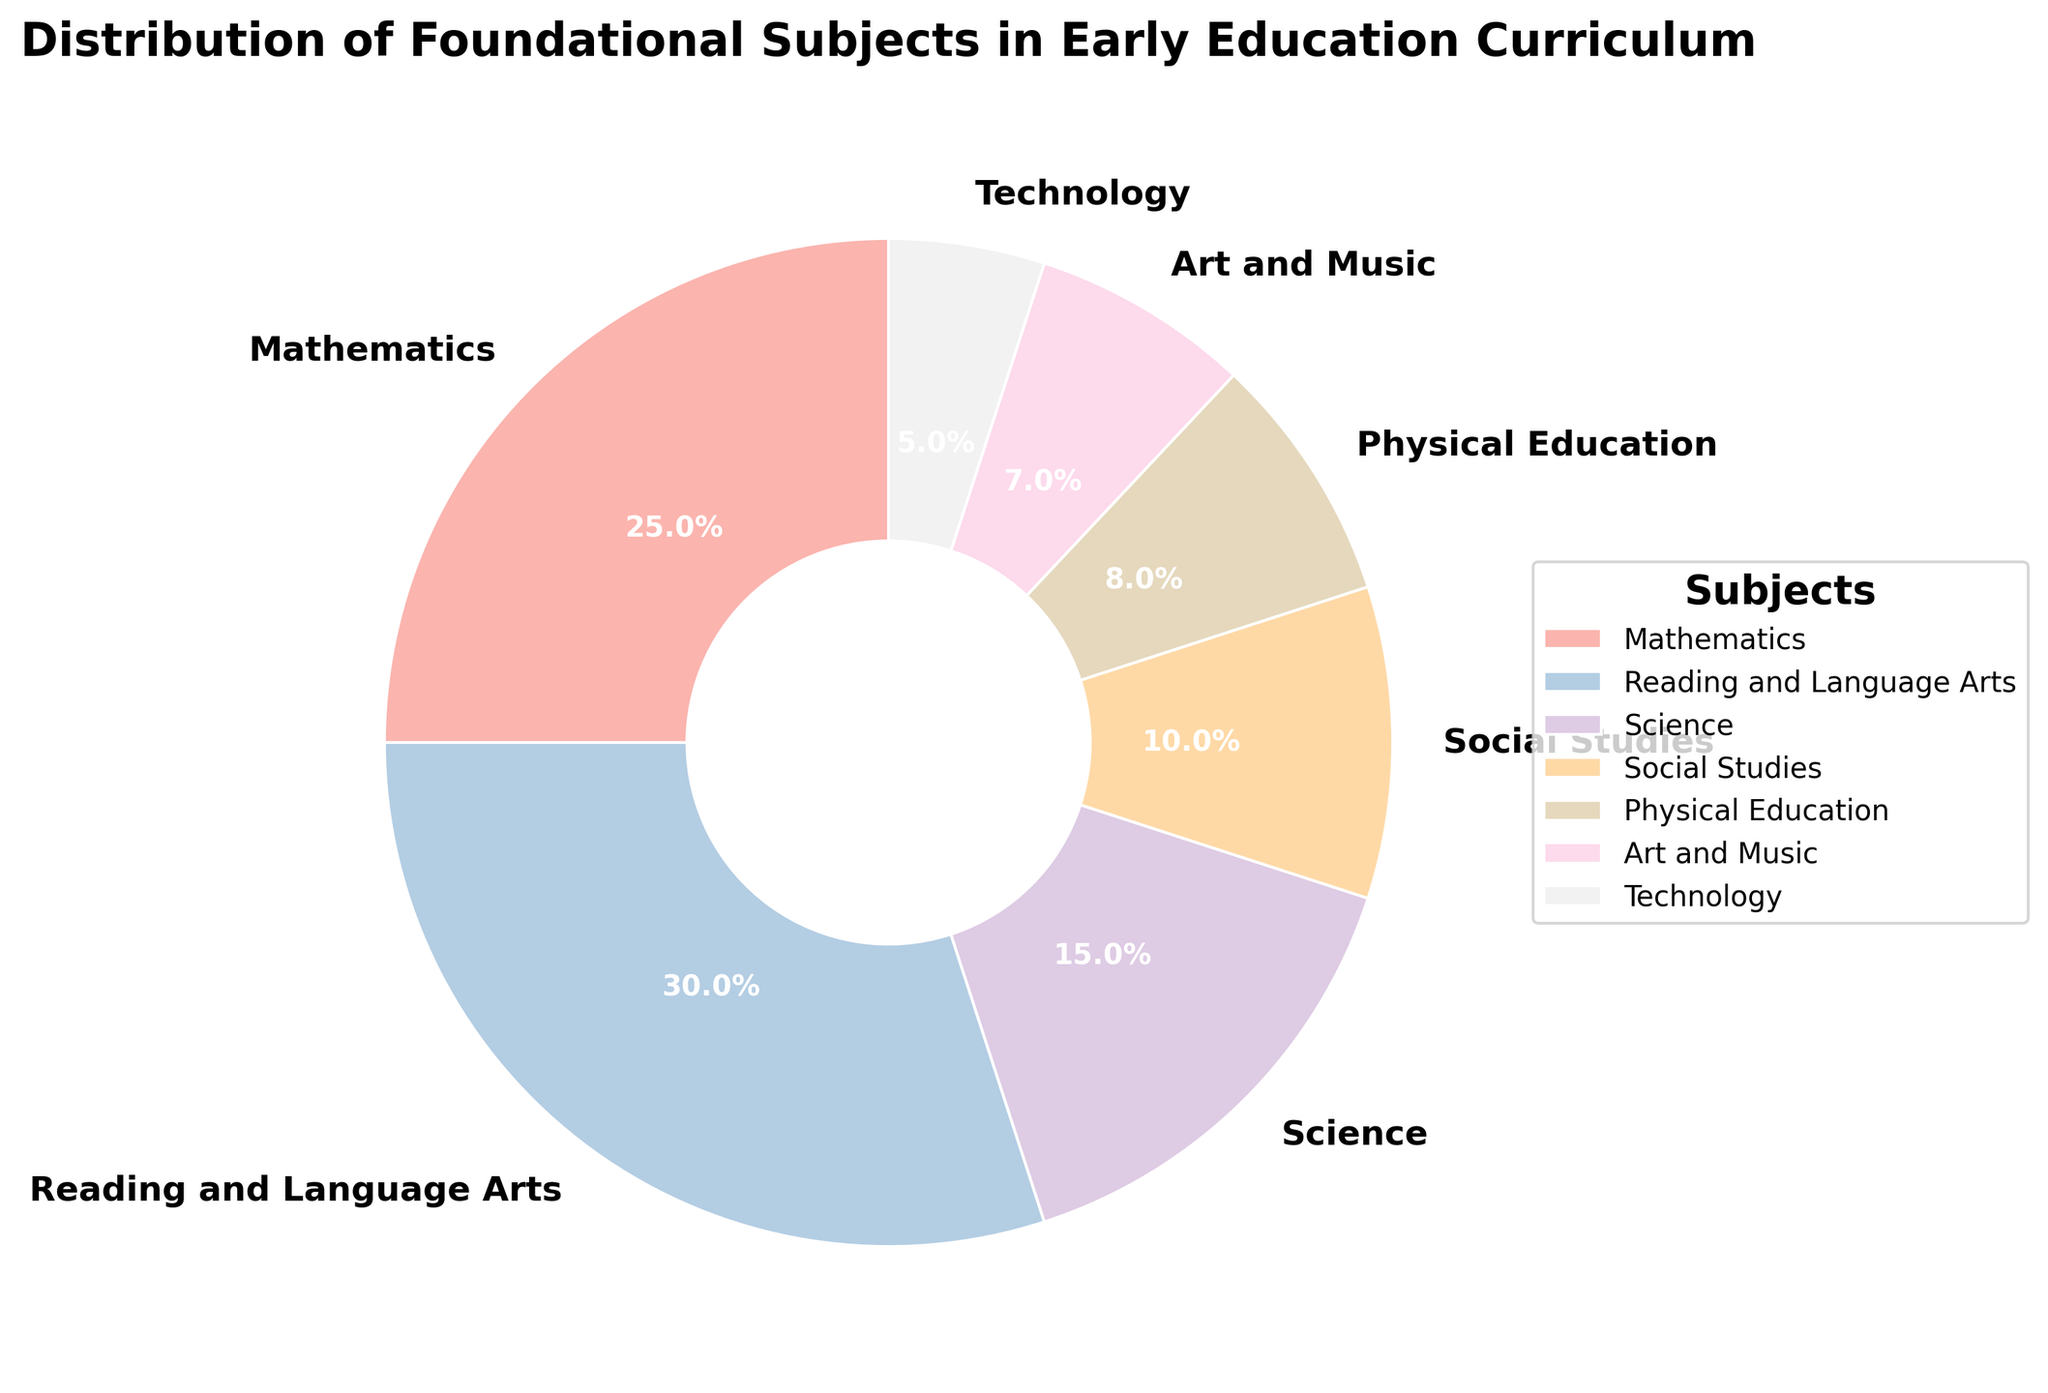What's the largest subject category by percentage? Identify the subject with the highest percentage value from the pie chart segments. Reading and Language Arts has the highest value of 30%.
Answer: Reading and Language Arts What's the combined percentage of Science and Social Studies? Look at the chart to find the percentages for Science (15%) and Social Studies (10%), then add them together: 15% + 10% = 25%.
Answer: 25% Which subject has a smaller distribution: Technology or Art and Music? Compare the percentages of the two subjects directly from the pie chart. Technology is 5% and Art and Music is 7%. Since 5% is smaller than 7%, Technology has a smaller distribution.
Answer: Technology What's the difference in percentage between Mathematics and Physical Education? Find the percentages for both subjects on the pie chart: Mathematics is 25% and Physical Education is 8%. Then subtract the smaller percentage from the larger one: 25% - 8% = 17%.
Answer: 17% What is the average percentage of all subjects? Add up all the percentages and divide by the number of subjects. Sum: 25% + 30% + 15% + 10% + 8% + 7% + 5% = 100%. Number of subjects: 7. Average: 100% / 7 ≈ 14.29%.
Answer: 14.29% How does the size of the Social Studies segment compare visually to the Physical Education segment? Look at the pie chart and note the relative sizes of the segments for each subject. The segment for Social Studies (10%) is slightly larger than that for Physical Education (8%).
Answer: Social Studies is slightly larger Which two subjects have the smallest combined percentage? Identify the two smallest percentages on the chart: Technology (5%) and Art and Music (7%). Combine them: 5% + 7% = 12%.
Answer: Technology and Art and Music Is the combined percentage of Mathematics and Science greater than Reading and Language Arts? Add the percentages for Mathematics (25%) and Science (15%): 25% + 15% = 40%. Compare it to Reading and Language Arts (30%). Since 40% is greater than 30%, the combined percentage is indeed greater.
Answer: Yes 